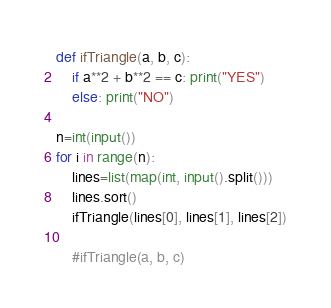Convert code to text. <code><loc_0><loc_0><loc_500><loc_500><_Python_>def ifTriangle(a, b, c):
    if a**2 + b**2 == c: print("YES")
    else: print("NO")

n=int(input())
for i in range(n):
    lines=list(map(int, input().split()))
    lines.sort()
    ifTriangle(lines[0], lines[1], lines[2])

    #ifTriangle(a, b, c)</code> 